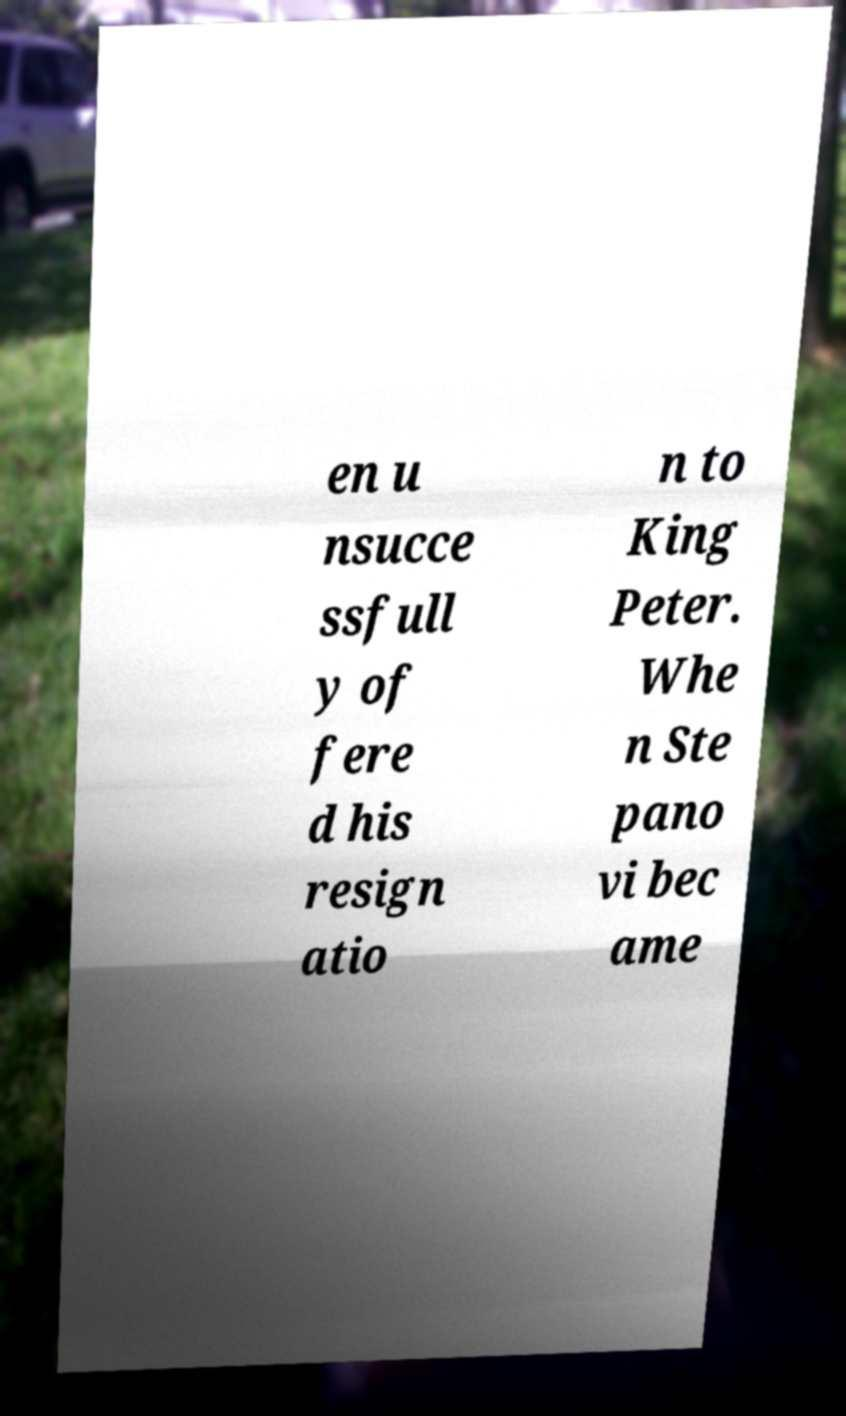Could you assist in decoding the text presented in this image and type it out clearly? en u nsucce ssfull y of fere d his resign atio n to King Peter. Whe n Ste pano vi bec ame 